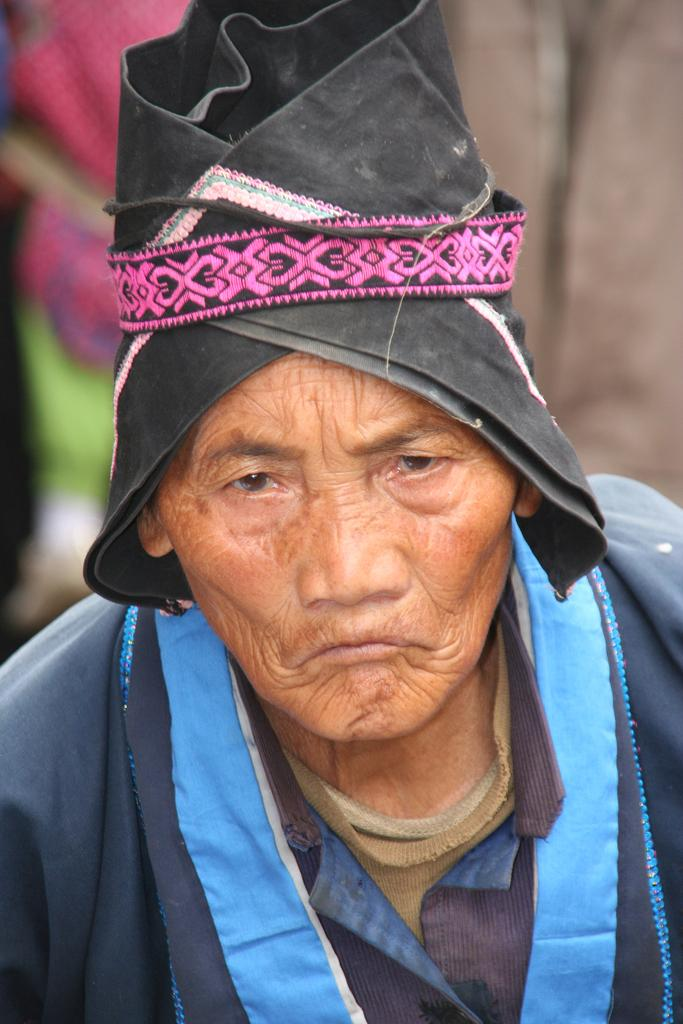Who is the main subject in the image? There is an old man in the image. What is the old man wearing? The old man is wearing a black coat. What is on the old man's head? The old man has a cloth on his head. Who is the friend of the old man in the image? There is no friend present in the image; it only features the old man. Who is the owner of the houses in the image? There are no houses present in the image, so it is not possible to determine the owner. 